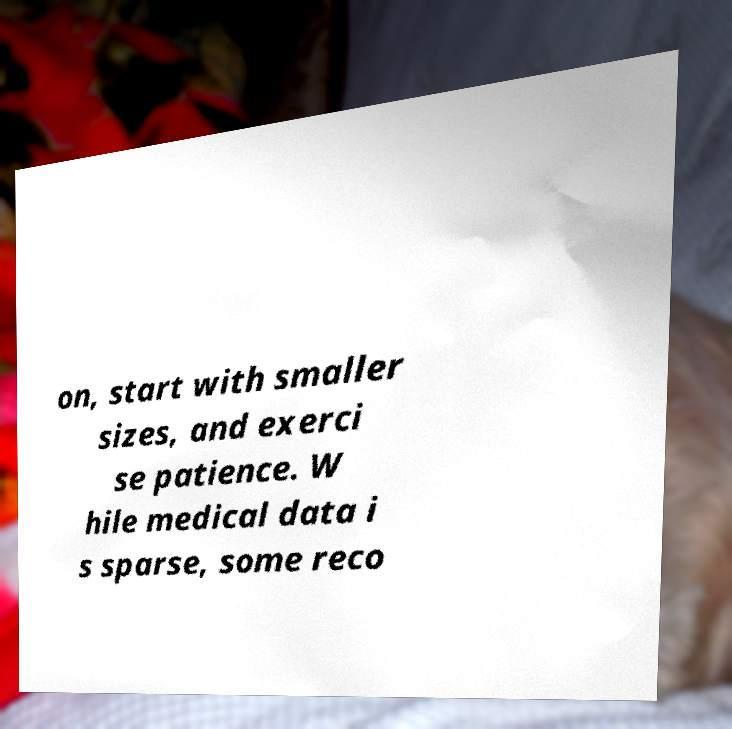I need the written content from this picture converted into text. Can you do that? on, start with smaller sizes, and exerci se patience. W hile medical data i s sparse, some reco 